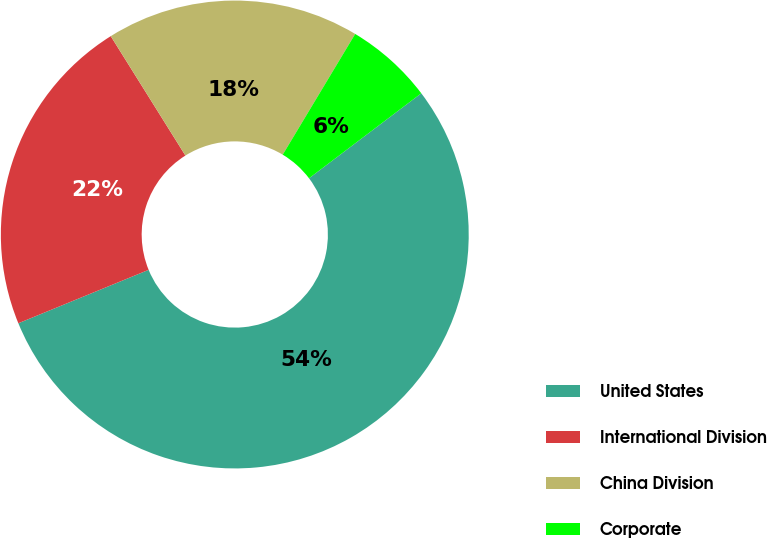<chart> <loc_0><loc_0><loc_500><loc_500><pie_chart><fcel>United States<fcel>International Division<fcel>China Division<fcel>Corporate<nl><fcel>54.12%<fcel>22.3%<fcel>17.5%<fcel>6.08%<nl></chart> 